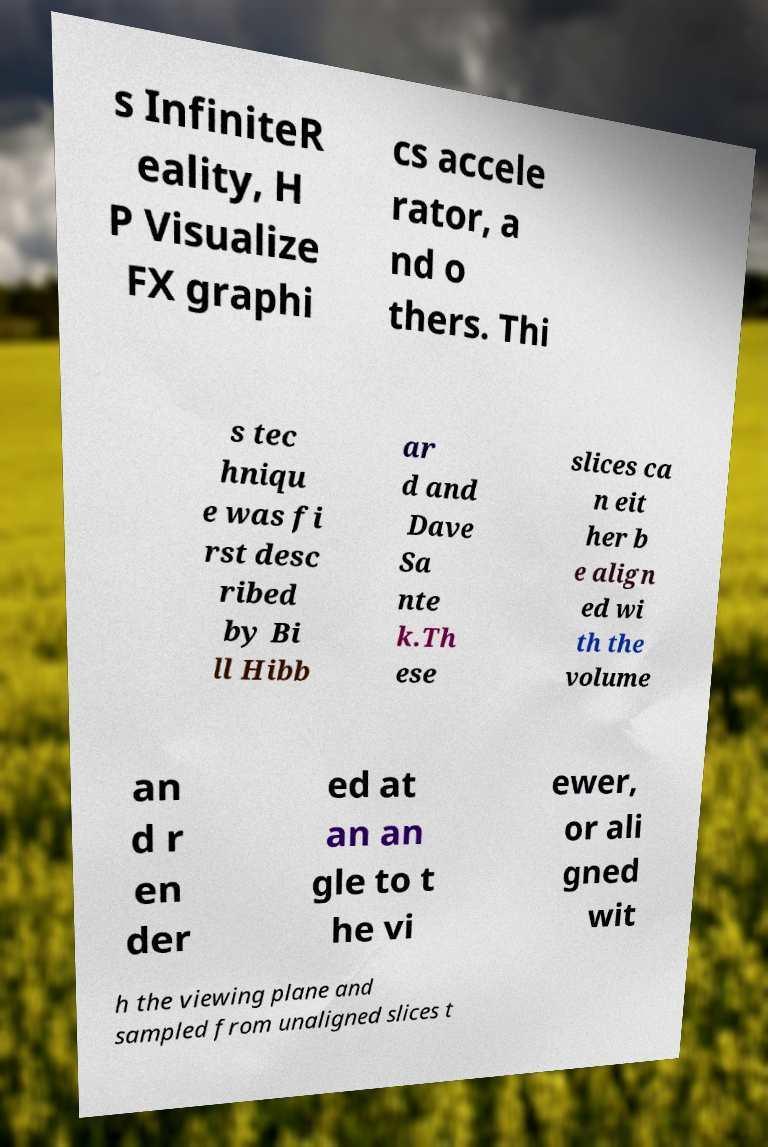There's text embedded in this image that I need extracted. Can you transcribe it verbatim? s InfiniteR eality, H P Visualize FX graphi cs accele rator, a nd o thers. Thi s tec hniqu e was fi rst desc ribed by Bi ll Hibb ar d and Dave Sa nte k.Th ese slices ca n eit her b e align ed wi th the volume an d r en der ed at an an gle to t he vi ewer, or ali gned wit h the viewing plane and sampled from unaligned slices t 